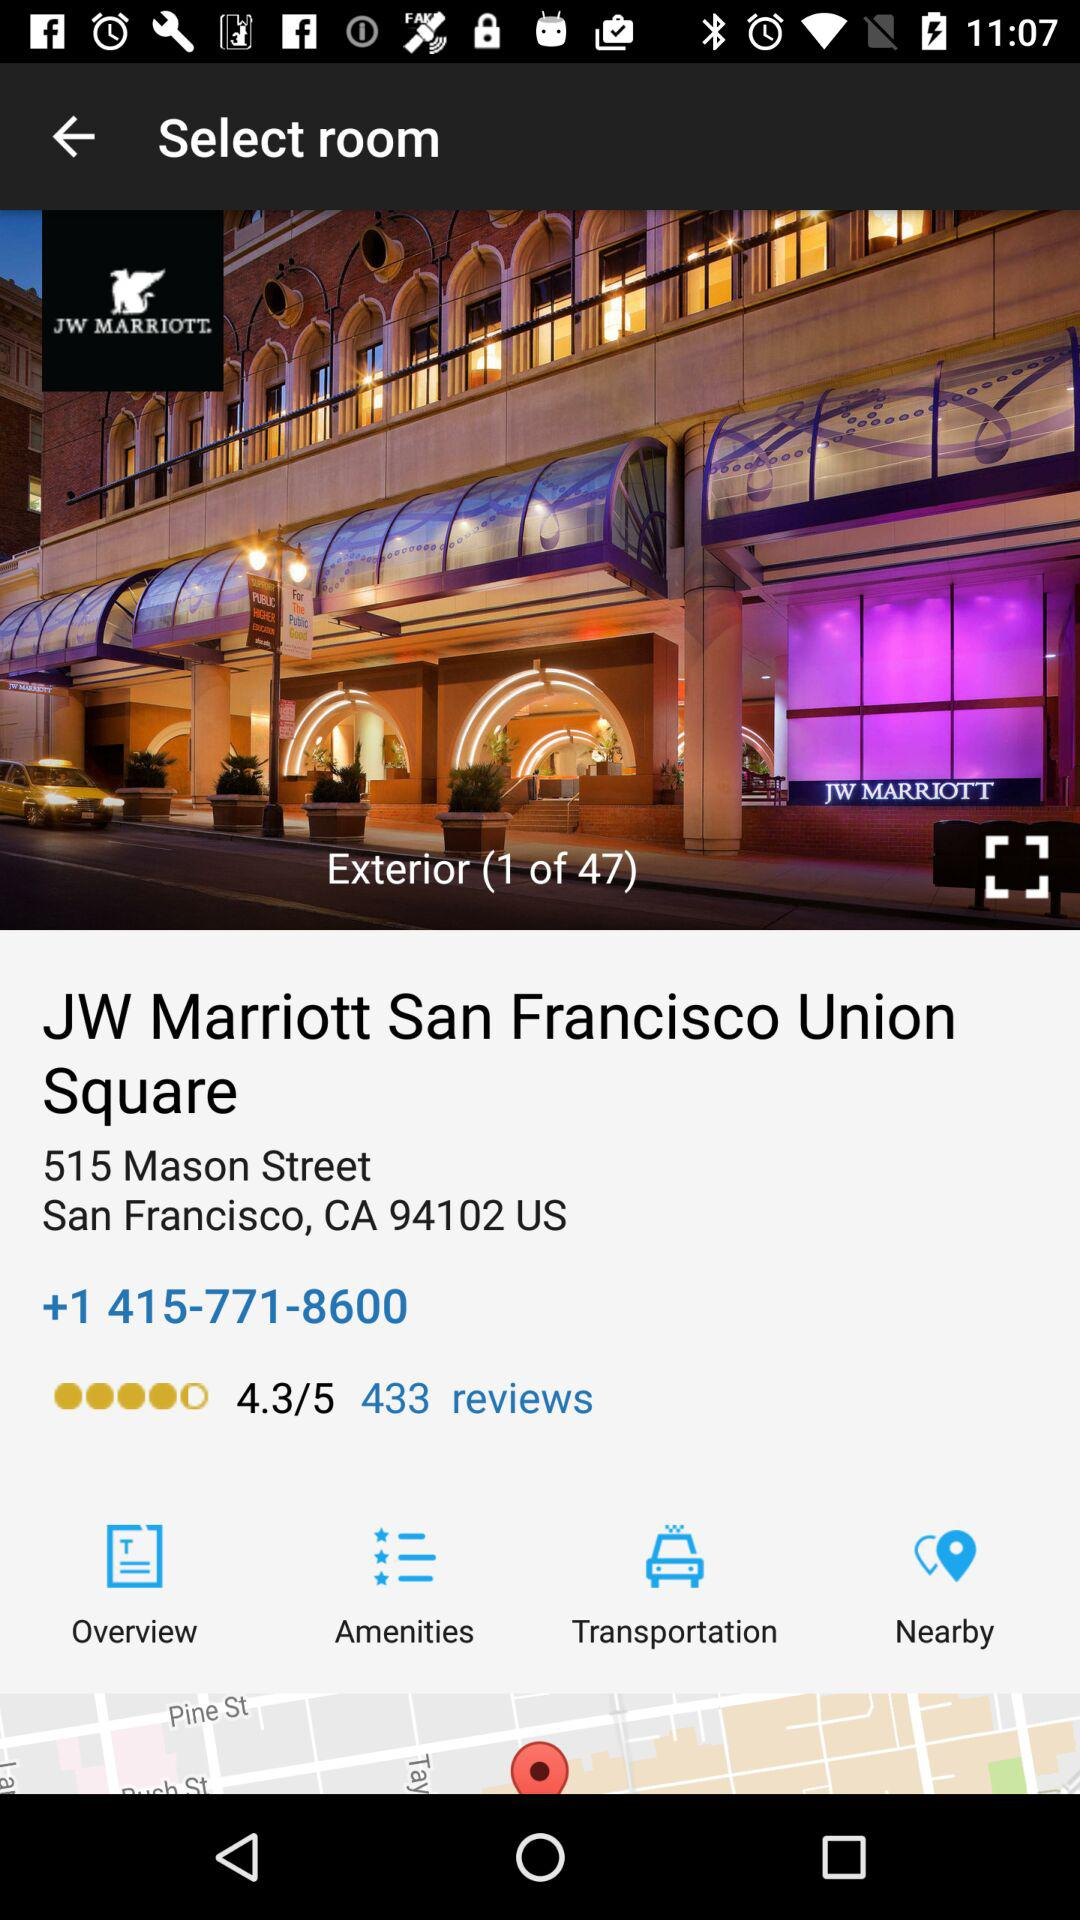What is the rating of JW Marriott? JW Marriott's rating is 4.3 out of 5. 